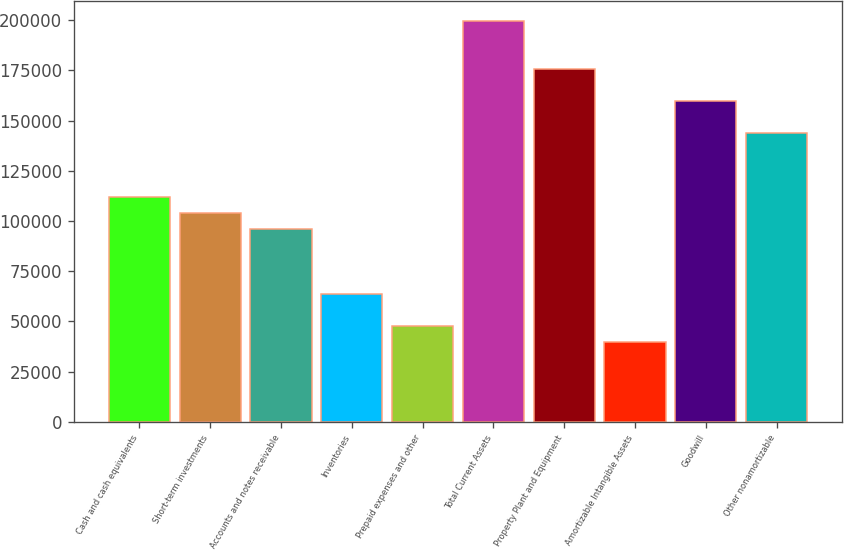Convert chart to OTSL. <chart><loc_0><loc_0><loc_500><loc_500><bar_chart><fcel>Cash and cash equivalents<fcel>Short-term investments<fcel>Accounts and notes receivable<fcel>Inventories<fcel>Prepaid expenses and other<fcel>Total Current Assets<fcel>Property Plant and Equipment<fcel>Amortizable Intangible Assets<fcel>Goodwill<fcel>Other nonamortizable<nl><fcel>111716<fcel>103738<fcel>95760<fcel>63848<fcel>47892<fcel>199474<fcel>175540<fcel>39914<fcel>159584<fcel>143628<nl></chart> 